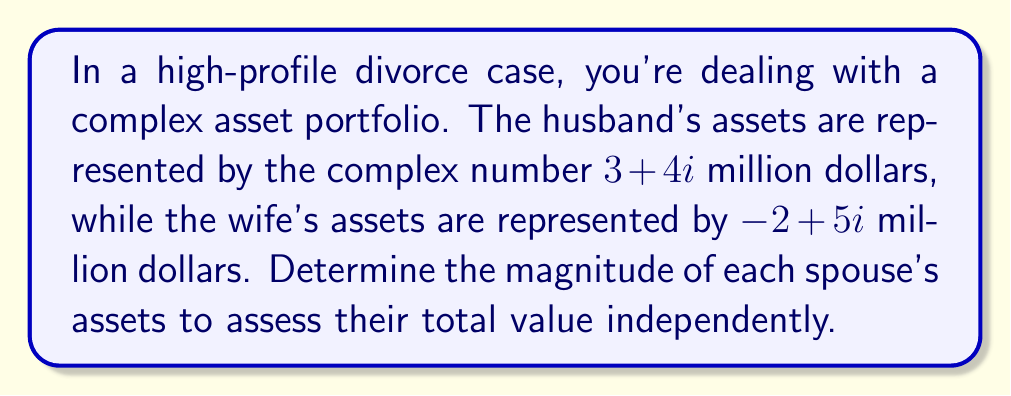Help me with this question. To determine the magnitude of a complex number, we use the formula:

$\text{Magnitude} = \sqrt{a^2 + b^2}$, where $a$ is the real part and $b$ is the imaginary part.

For the husband's assets: $3 + 4i$
1. $a = 3$, $b = 4$
2. $\sqrt{3^2 + 4^2}$
3. $\sqrt{9 + 16}$
4. $\sqrt{25}$
5. $5$ million dollars

For the wife's assets: $-2 + 5i$
1. $a = -2$, $b = 5$
2. $\sqrt{(-2)^2 + 5^2}$
3. $\sqrt{4 + 25}$
4. $\sqrt{29}$
5. $\approx 5.39$ million dollars

The magnitude represents the total value of assets for each spouse, regardless of the complex nature of their portfolio.
Answer: Husband's assets: $5$ million; Wife's assets: $\sqrt{29} \approx 5.39$ million 